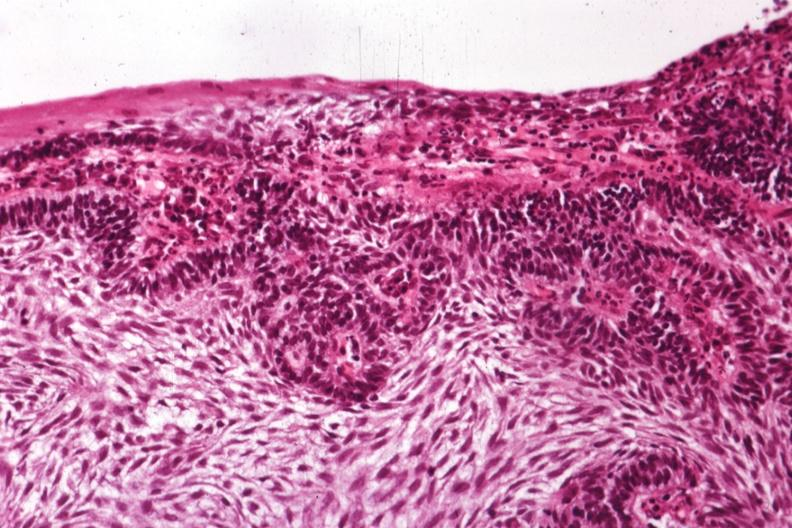what is present?
Answer the question using a single word or phrase. Ameloblastoma 